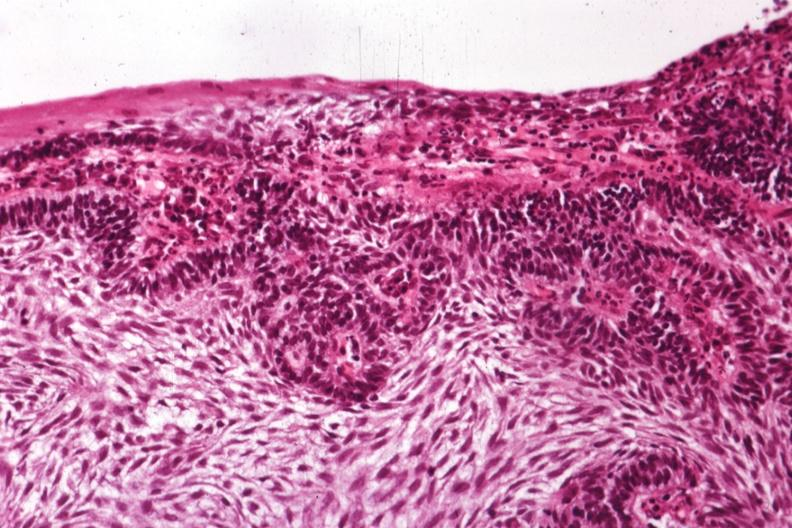what is present?
Answer the question using a single word or phrase. Ameloblastoma 